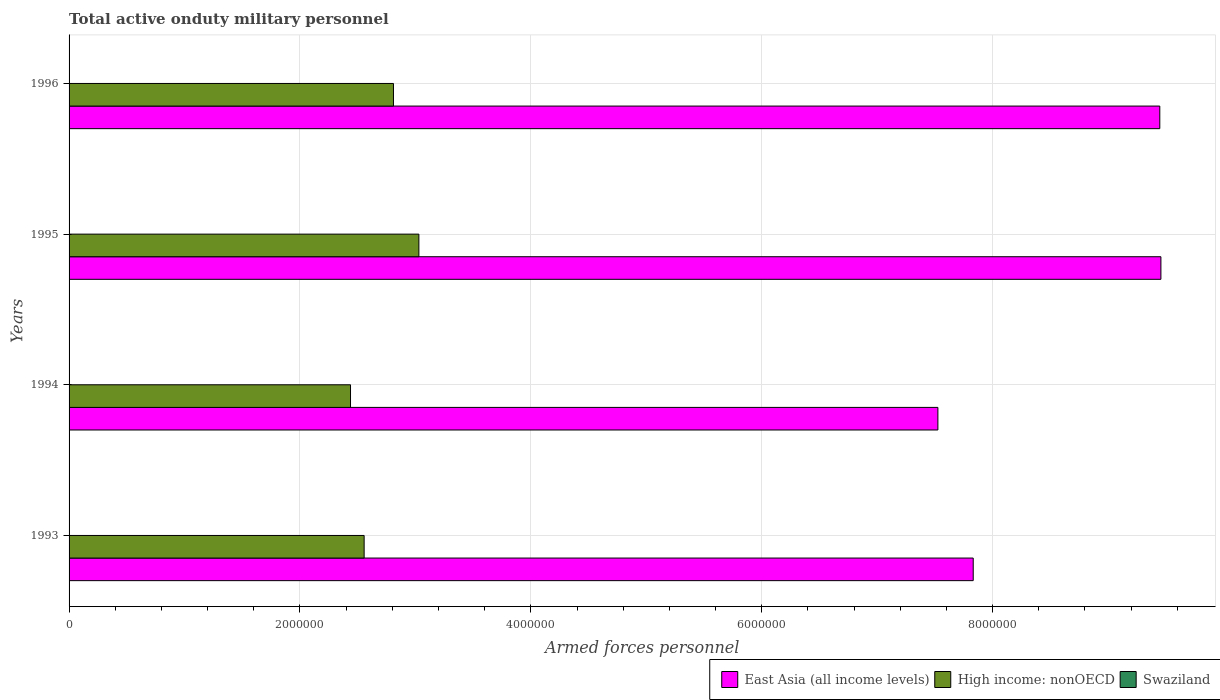What is the label of the 3rd group of bars from the top?
Make the answer very short. 1994. In how many cases, is the number of bars for a given year not equal to the number of legend labels?
Your response must be concise. 0. What is the number of armed forces personnel in High income: nonOECD in 1995?
Ensure brevity in your answer.  3.03e+06. Across all years, what is the maximum number of armed forces personnel in Swaziland?
Provide a short and direct response. 3000. Across all years, what is the minimum number of armed forces personnel in High income: nonOECD?
Your response must be concise. 2.44e+06. In which year was the number of armed forces personnel in East Asia (all income levels) maximum?
Keep it short and to the point. 1995. In which year was the number of armed forces personnel in Swaziland minimum?
Your answer should be compact. 1993. What is the total number of armed forces personnel in Swaziland in the graph?
Keep it short and to the point. 1.20e+04. What is the difference between the number of armed forces personnel in Swaziland in 1993 and that in 1994?
Provide a short and direct response. 0. What is the difference between the number of armed forces personnel in Swaziland in 1993 and the number of armed forces personnel in East Asia (all income levels) in 1996?
Your response must be concise. -9.45e+06. What is the average number of armed forces personnel in Swaziland per year?
Provide a short and direct response. 3000. In the year 1993, what is the difference between the number of armed forces personnel in East Asia (all income levels) and number of armed forces personnel in High income: nonOECD?
Provide a short and direct response. 5.28e+06. What is the ratio of the number of armed forces personnel in East Asia (all income levels) in 1993 to that in 1994?
Offer a terse response. 1.04. Is the number of armed forces personnel in East Asia (all income levels) in 1993 less than that in 1996?
Provide a succinct answer. Yes. Is the difference between the number of armed forces personnel in East Asia (all income levels) in 1995 and 1996 greater than the difference between the number of armed forces personnel in High income: nonOECD in 1995 and 1996?
Your answer should be compact. No. What is the difference between the highest and the second highest number of armed forces personnel in Swaziland?
Give a very brief answer. 0. What is the difference between the highest and the lowest number of armed forces personnel in East Asia (all income levels)?
Provide a short and direct response. 1.93e+06. Is the sum of the number of armed forces personnel in East Asia (all income levels) in 1993 and 1994 greater than the maximum number of armed forces personnel in Swaziland across all years?
Your response must be concise. Yes. What does the 2nd bar from the top in 1994 represents?
Provide a succinct answer. High income: nonOECD. What does the 3rd bar from the bottom in 1993 represents?
Offer a terse response. Swaziland. How many years are there in the graph?
Make the answer very short. 4. Does the graph contain any zero values?
Provide a succinct answer. No. Does the graph contain grids?
Your answer should be compact. Yes. Where does the legend appear in the graph?
Ensure brevity in your answer.  Bottom right. How many legend labels are there?
Offer a terse response. 3. How are the legend labels stacked?
Offer a very short reply. Horizontal. What is the title of the graph?
Provide a succinct answer. Total active onduty military personnel. What is the label or title of the X-axis?
Your answer should be compact. Armed forces personnel. What is the label or title of the Y-axis?
Your answer should be very brief. Years. What is the Armed forces personnel of East Asia (all income levels) in 1993?
Provide a short and direct response. 7.83e+06. What is the Armed forces personnel in High income: nonOECD in 1993?
Your answer should be compact. 2.56e+06. What is the Armed forces personnel in Swaziland in 1993?
Offer a very short reply. 3000. What is the Armed forces personnel of East Asia (all income levels) in 1994?
Give a very brief answer. 7.53e+06. What is the Armed forces personnel in High income: nonOECD in 1994?
Your response must be concise. 2.44e+06. What is the Armed forces personnel of Swaziland in 1994?
Ensure brevity in your answer.  3000. What is the Armed forces personnel of East Asia (all income levels) in 1995?
Offer a very short reply. 9.46e+06. What is the Armed forces personnel in High income: nonOECD in 1995?
Keep it short and to the point. 3.03e+06. What is the Armed forces personnel in Swaziland in 1995?
Give a very brief answer. 3000. What is the Armed forces personnel of East Asia (all income levels) in 1996?
Provide a succinct answer. 9.45e+06. What is the Armed forces personnel in High income: nonOECD in 1996?
Ensure brevity in your answer.  2.81e+06. What is the Armed forces personnel of Swaziland in 1996?
Offer a terse response. 3000. Across all years, what is the maximum Armed forces personnel of East Asia (all income levels)?
Your response must be concise. 9.46e+06. Across all years, what is the maximum Armed forces personnel of High income: nonOECD?
Offer a terse response. 3.03e+06. Across all years, what is the maximum Armed forces personnel in Swaziland?
Your response must be concise. 3000. Across all years, what is the minimum Armed forces personnel in East Asia (all income levels)?
Your response must be concise. 7.53e+06. Across all years, what is the minimum Armed forces personnel of High income: nonOECD?
Make the answer very short. 2.44e+06. Across all years, what is the minimum Armed forces personnel of Swaziland?
Provide a succinct answer. 3000. What is the total Armed forces personnel in East Asia (all income levels) in the graph?
Ensure brevity in your answer.  3.43e+07. What is the total Armed forces personnel of High income: nonOECD in the graph?
Your response must be concise. 1.08e+07. What is the total Armed forces personnel of Swaziland in the graph?
Make the answer very short. 1.20e+04. What is the difference between the Armed forces personnel in East Asia (all income levels) in 1993 and that in 1994?
Ensure brevity in your answer.  3.06e+05. What is the difference between the Armed forces personnel of High income: nonOECD in 1993 and that in 1994?
Make the answer very short. 1.18e+05. What is the difference between the Armed forces personnel in East Asia (all income levels) in 1993 and that in 1995?
Give a very brief answer. -1.63e+06. What is the difference between the Armed forces personnel of High income: nonOECD in 1993 and that in 1995?
Ensure brevity in your answer.  -4.74e+05. What is the difference between the Armed forces personnel in Swaziland in 1993 and that in 1995?
Offer a terse response. 0. What is the difference between the Armed forces personnel of East Asia (all income levels) in 1993 and that in 1996?
Your answer should be compact. -1.62e+06. What is the difference between the Armed forces personnel of High income: nonOECD in 1993 and that in 1996?
Keep it short and to the point. -2.54e+05. What is the difference between the Armed forces personnel in East Asia (all income levels) in 1994 and that in 1995?
Your answer should be very brief. -1.93e+06. What is the difference between the Armed forces personnel in High income: nonOECD in 1994 and that in 1995?
Your answer should be very brief. -5.92e+05. What is the difference between the Armed forces personnel in Swaziland in 1994 and that in 1995?
Your response must be concise. 0. What is the difference between the Armed forces personnel of East Asia (all income levels) in 1994 and that in 1996?
Provide a succinct answer. -1.92e+06. What is the difference between the Armed forces personnel in High income: nonOECD in 1994 and that in 1996?
Make the answer very short. -3.72e+05. What is the difference between the Armed forces personnel of East Asia (all income levels) in 1995 and that in 1996?
Your response must be concise. 9530. What is the difference between the Armed forces personnel in High income: nonOECD in 1995 and that in 1996?
Your answer should be very brief. 2.20e+05. What is the difference between the Armed forces personnel in Swaziland in 1995 and that in 1996?
Give a very brief answer. 0. What is the difference between the Armed forces personnel of East Asia (all income levels) in 1993 and the Armed forces personnel of High income: nonOECD in 1994?
Offer a terse response. 5.39e+06. What is the difference between the Armed forces personnel in East Asia (all income levels) in 1993 and the Armed forces personnel in Swaziland in 1994?
Offer a very short reply. 7.83e+06. What is the difference between the Armed forces personnel in High income: nonOECD in 1993 and the Armed forces personnel in Swaziland in 1994?
Ensure brevity in your answer.  2.55e+06. What is the difference between the Armed forces personnel in East Asia (all income levels) in 1993 and the Armed forces personnel in High income: nonOECD in 1995?
Your response must be concise. 4.80e+06. What is the difference between the Armed forces personnel in East Asia (all income levels) in 1993 and the Armed forces personnel in Swaziland in 1995?
Give a very brief answer. 7.83e+06. What is the difference between the Armed forces personnel in High income: nonOECD in 1993 and the Armed forces personnel in Swaziland in 1995?
Your answer should be compact. 2.55e+06. What is the difference between the Armed forces personnel of East Asia (all income levels) in 1993 and the Armed forces personnel of High income: nonOECD in 1996?
Your response must be concise. 5.02e+06. What is the difference between the Armed forces personnel in East Asia (all income levels) in 1993 and the Armed forces personnel in Swaziland in 1996?
Provide a short and direct response. 7.83e+06. What is the difference between the Armed forces personnel of High income: nonOECD in 1993 and the Armed forces personnel of Swaziland in 1996?
Give a very brief answer. 2.55e+06. What is the difference between the Armed forces personnel of East Asia (all income levels) in 1994 and the Armed forces personnel of High income: nonOECD in 1995?
Provide a short and direct response. 4.50e+06. What is the difference between the Armed forces personnel in East Asia (all income levels) in 1994 and the Armed forces personnel in Swaziland in 1995?
Your answer should be compact. 7.52e+06. What is the difference between the Armed forces personnel in High income: nonOECD in 1994 and the Armed forces personnel in Swaziland in 1995?
Make the answer very short. 2.44e+06. What is the difference between the Armed forces personnel in East Asia (all income levels) in 1994 and the Armed forces personnel in High income: nonOECD in 1996?
Provide a succinct answer. 4.72e+06. What is the difference between the Armed forces personnel of East Asia (all income levels) in 1994 and the Armed forces personnel of Swaziland in 1996?
Make the answer very short. 7.52e+06. What is the difference between the Armed forces personnel of High income: nonOECD in 1994 and the Armed forces personnel of Swaziland in 1996?
Provide a short and direct response. 2.44e+06. What is the difference between the Armed forces personnel of East Asia (all income levels) in 1995 and the Armed forces personnel of High income: nonOECD in 1996?
Your response must be concise. 6.65e+06. What is the difference between the Armed forces personnel of East Asia (all income levels) in 1995 and the Armed forces personnel of Swaziland in 1996?
Provide a short and direct response. 9.45e+06. What is the difference between the Armed forces personnel of High income: nonOECD in 1995 and the Armed forces personnel of Swaziland in 1996?
Your answer should be very brief. 3.03e+06. What is the average Armed forces personnel of East Asia (all income levels) per year?
Provide a succinct answer. 8.57e+06. What is the average Armed forces personnel of High income: nonOECD per year?
Provide a short and direct response. 2.71e+06. What is the average Armed forces personnel in Swaziland per year?
Provide a short and direct response. 3000. In the year 1993, what is the difference between the Armed forces personnel of East Asia (all income levels) and Armed forces personnel of High income: nonOECD?
Provide a succinct answer. 5.28e+06. In the year 1993, what is the difference between the Armed forces personnel in East Asia (all income levels) and Armed forces personnel in Swaziland?
Offer a terse response. 7.83e+06. In the year 1993, what is the difference between the Armed forces personnel of High income: nonOECD and Armed forces personnel of Swaziland?
Offer a terse response. 2.55e+06. In the year 1994, what is the difference between the Armed forces personnel of East Asia (all income levels) and Armed forces personnel of High income: nonOECD?
Offer a terse response. 5.09e+06. In the year 1994, what is the difference between the Armed forces personnel in East Asia (all income levels) and Armed forces personnel in Swaziland?
Your answer should be very brief. 7.52e+06. In the year 1994, what is the difference between the Armed forces personnel in High income: nonOECD and Armed forces personnel in Swaziland?
Offer a terse response. 2.44e+06. In the year 1995, what is the difference between the Armed forces personnel of East Asia (all income levels) and Armed forces personnel of High income: nonOECD?
Keep it short and to the point. 6.43e+06. In the year 1995, what is the difference between the Armed forces personnel in East Asia (all income levels) and Armed forces personnel in Swaziland?
Provide a short and direct response. 9.45e+06. In the year 1995, what is the difference between the Armed forces personnel of High income: nonOECD and Armed forces personnel of Swaziland?
Keep it short and to the point. 3.03e+06. In the year 1996, what is the difference between the Armed forces personnel in East Asia (all income levels) and Armed forces personnel in High income: nonOECD?
Offer a very short reply. 6.64e+06. In the year 1996, what is the difference between the Armed forces personnel in East Asia (all income levels) and Armed forces personnel in Swaziland?
Your response must be concise. 9.45e+06. In the year 1996, what is the difference between the Armed forces personnel in High income: nonOECD and Armed forces personnel in Swaziland?
Offer a terse response. 2.81e+06. What is the ratio of the Armed forces personnel in East Asia (all income levels) in 1993 to that in 1994?
Provide a short and direct response. 1.04. What is the ratio of the Armed forces personnel of High income: nonOECD in 1993 to that in 1994?
Offer a terse response. 1.05. What is the ratio of the Armed forces personnel of East Asia (all income levels) in 1993 to that in 1995?
Ensure brevity in your answer.  0.83. What is the ratio of the Armed forces personnel in High income: nonOECD in 1993 to that in 1995?
Provide a short and direct response. 0.84. What is the ratio of the Armed forces personnel of Swaziland in 1993 to that in 1995?
Keep it short and to the point. 1. What is the ratio of the Armed forces personnel in East Asia (all income levels) in 1993 to that in 1996?
Offer a terse response. 0.83. What is the ratio of the Armed forces personnel of High income: nonOECD in 1993 to that in 1996?
Give a very brief answer. 0.91. What is the ratio of the Armed forces personnel in Swaziland in 1993 to that in 1996?
Offer a terse response. 1. What is the ratio of the Armed forces personnel of East Asia (all income levels) in 1994 to that in 1995?
Your response must be concise. 0.8. What is the ratio of the Armed forces personnel of High income: nonOECD in 1994 to that in 1995?
Provide a succinct answer. 0.8. What is the ratio of the Armed forces personnel in Swaziland in 1994 to that in 1995?
Provide a succinct answer. 1. What is the ratio of the Armed forces personnel in East Asia (all income levels) in 1994 to that in 1996?
Your answer should be very brief. 0.8. What is the ratio of the Armed forces personnel in High income: nonOECD in 1994 to that in 1996?
Make the answer very short. 0.87. What is the ratio of the Armed forces personnel in Swaziland in 1994 to that in 1996?
Keep it short and to the point. 1. What is the ratio of the Armed forces personnel in East Asia (all income levels) in 1995 to that in 1996?
Offer a very short reply. 1. What is the ratio of the Armed forces personnel in High income: nonOECD in 1995 to that in 1996?
Provide a short and direct response. 1.08. What is the difference between the highest and the second highest Armed forces personnel of East Asia (all income levels)?
Keep it short and to the point. 9530. What is the difference between the highest and the second highest Armed forces personnel in High income: nonOECD?
Offer a terse response. 2.20e+05. What is the difference between the highest and the second highest Armed forces personnel of Swaziland?
Your answer should be compact. 0. What is the difference between the highest and the lowest Armed forces personnel in East Asia (all income levels)?
Ensure brevity in your answer.  1.93e+06. What is the difference between the highest and the lowest Armed forces personnel of High income: nonOECD?
Give a very brief answer. 5.92e+05. What is the difference between the highest and the lowest Armed forces personnel in Swaziland?
Keep it short and to the point. 0. 